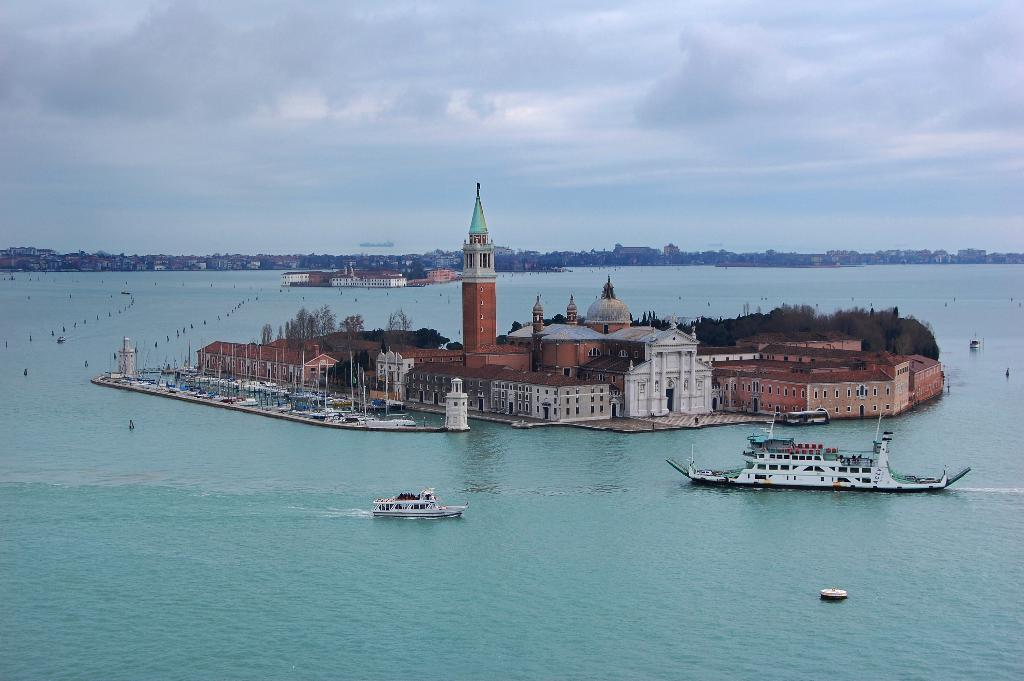What type of structures can be seen in the image? There are buildings in the image. What natural elements are present in the image? There are trees in the image. What type of vehicles can be seen in the image? There are boats and ships in the image. What is the primary setting of the image? The water is visible in the image. What can be seen in the background of the image? There are buildings and the sky in the background of the image. Can you recite the verse that is written on the side of the ship in the image? There is no verse written on the side of the ship in the image. How many icicles are hanging from the trees in the image? There are no icicles present in the image, as it does not depict a winter scene. 